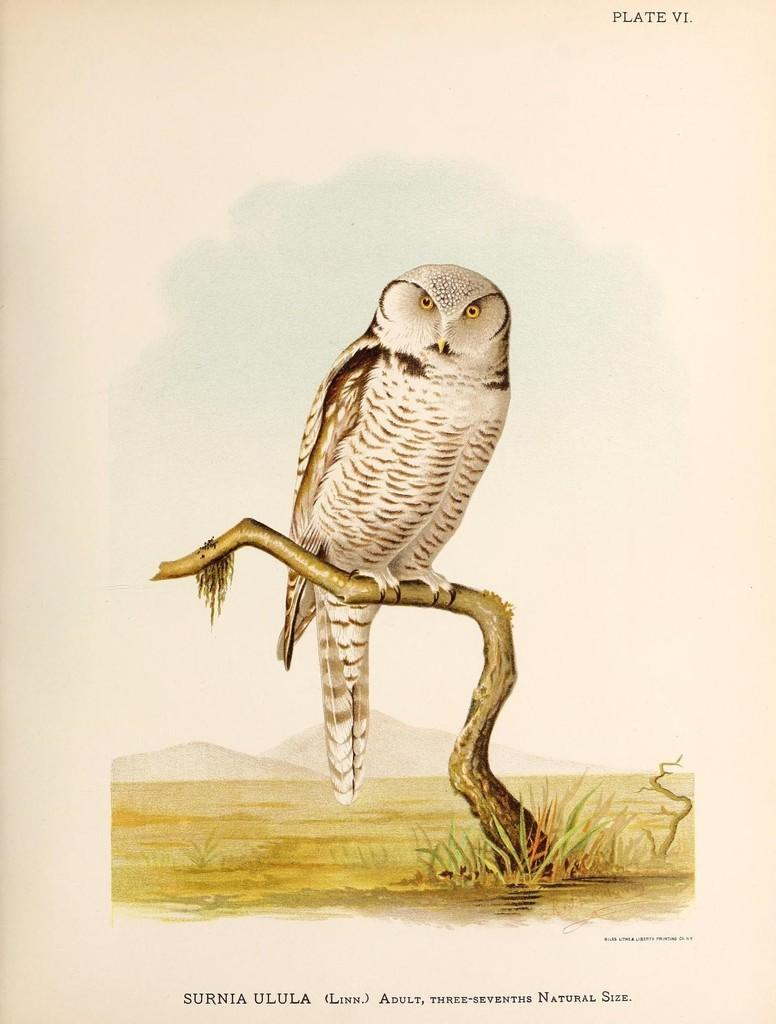What is depicted in the painting in the image? There is a painting of an owl in the image. Where is the owl sitting in the painting? The owl is sitting on a branch of a tree. What type of vegetation can be seen near the owl? There is grass visible near the owl. Can you tell me how many icicles are hanging from the owl's face in the image? There are no icicles present in the image, and the owl's face is not visible. 